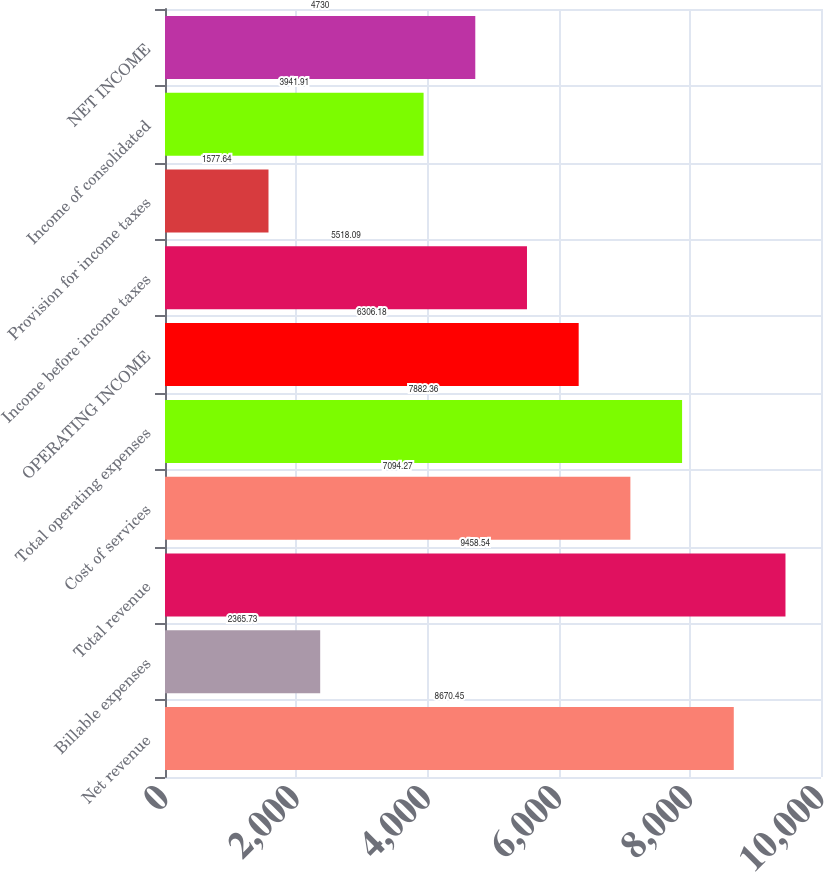Convert chart. <chart><loc_0><loc_0><loc_500><loc_500><bar_chart><fcel>Net revenue<fcel>Billable expenses<fcel>Total revenue<fcel>Cost of services<fcel>Total operating expenses<fcel>OPERATING INCOME<fcel>Income before income taxes<fcel>Provision for income taxes<fcel>Income of consolidated<fcel>NET INCOME<nl><fcel>8670.45<fcel>2365.73<fcel>9458.54<fcel>7094.27<fcel>7882.36<fcel>6306.18<fcel>5518.09<fcel>1577.64<fcel>3941.91<fcel>4730<nl></chart> 